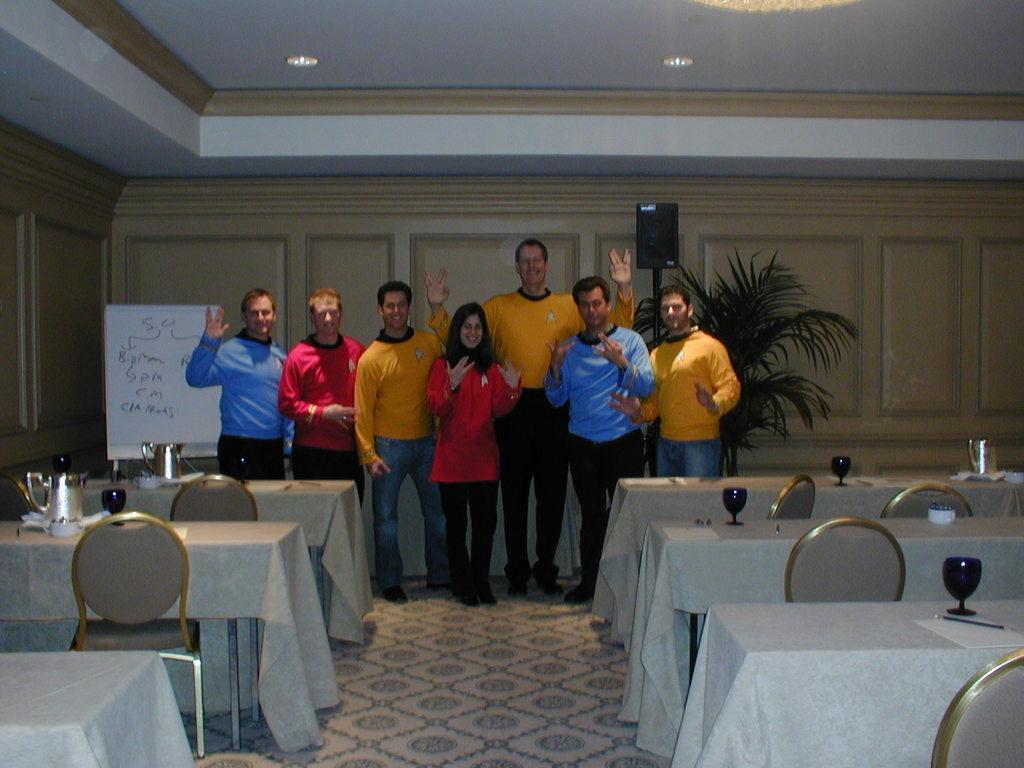Can you describe this image briefly? In this image, we can see some chairs and tables. These tables contains glasses and jugs. There are some persons in the middle of the image standing and wearing clothes. There is a plant and speaker in front of the wall. There is a board on the left side of the image. There are lights on the ceiling which is at the top of the image. 